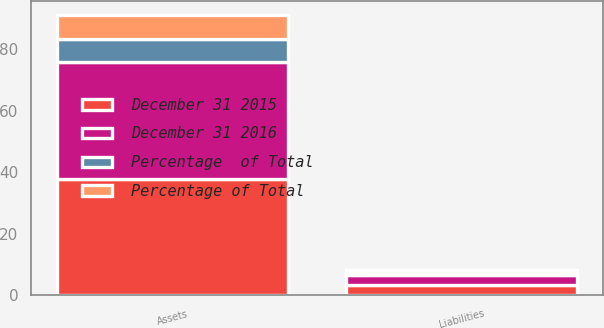<chart> <loc_0><loc_0><loc_500><loc_500><stacked_bar_chart><ecel><fcel>Assets<fcel>Liabilities<nl><fcel>December 31 2015<fcel>37.7<fcel>3.5<nl><fcel>Percentage of Total<fcel>7.6<fcel>0.8<nl><fcel>December 31 2016<fcel>38.1<fcel>3.1<nl><fcel>Percentage  of Total<fcel>7.7<fcel>0.8<nl></chart> 